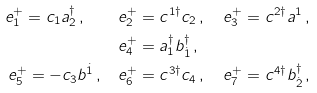Convert formula to latex. <formula><loc_0><loc_0><loc_500><loc_500>e ^ { + } _ { 1 } = c _ { 1 } a _ { 2 } ^ { \dagger } \, , \quad & e ^ { + } _ { 2 } = c ^ { 1 \dagger } c _ { 2 } \, , \quad e ^ { + } _ { 3 } = c ^ { 2 \dagger } a ^ { 1 } \, , \\ & e ^ { + } _ { 4 } = a _ { 1 } ^ { \dagger } b _ { \dot { 1 } } ^ { \dagger } \, , \quad \\ e ^ { + } _ { 5 } = - c _ { 3 } b ^ { \dot { 1 } } \, , \quad & e ^ { + } _ { 6 } = c ^ { 3 \dagger } c _ { 4 } \, , \quad e ^ { + } _ { 7 } = c ^ { 4 \dagger } b _ { \dot { 2 } } ^ { \dagger } \, ,</formula> 